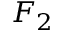<formula> <loc_0><loc_0><loc_500><loc_500>F _ { 2 }</formula> 